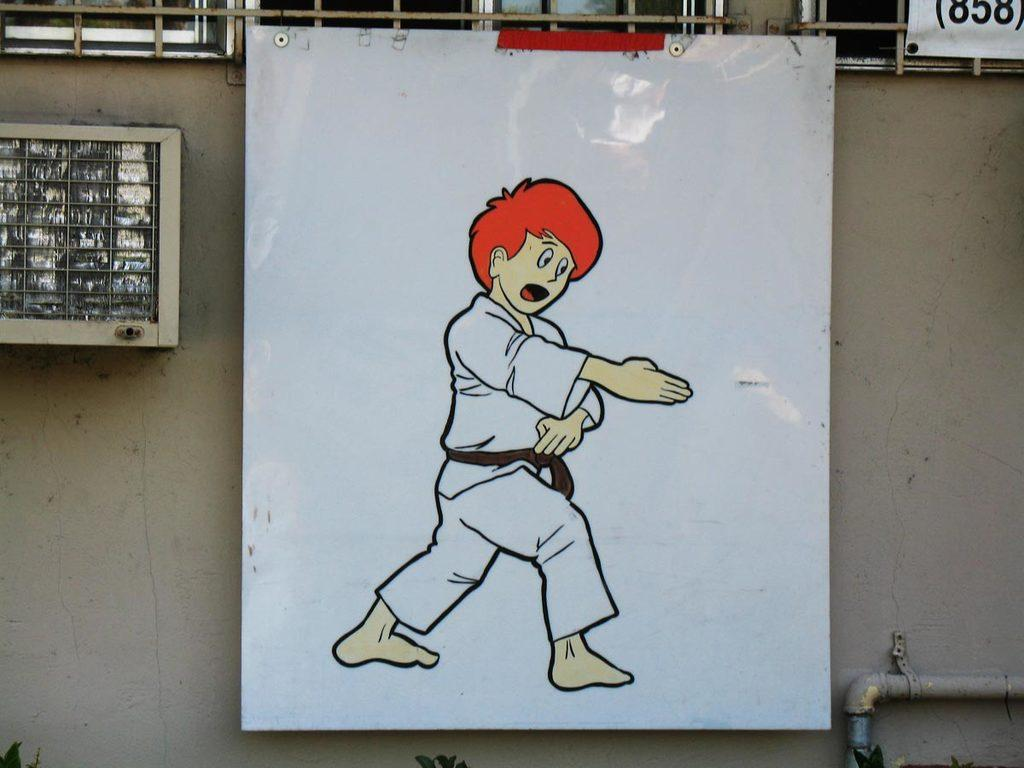What is the main object in the image? There is a whiteboard in the image. What is depicted on the whiteboard? There is a drawing of a person on the whiteboard. What can be observed about the person in the drawing? The person in the drawing is wearing clothes. What can be seen in the background of the image? There is a wall visible in the image, as well as a fence and a pipe. How many girls are interacting with the crook in the image? There is no crook or girls present in the image. What type of insect can be seen crawling on the fence in the image? There are no insects visible in the image; only the fence and other background elements are present. 